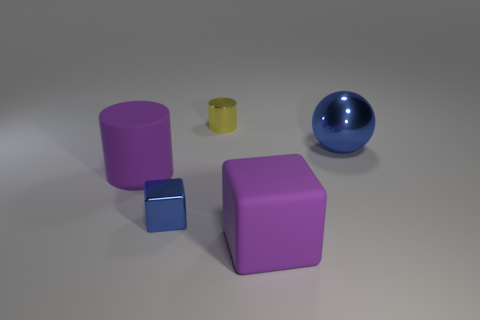Add 3 big brown blocks. How many objects exist? 8 Subtract all purple cylinders. How many cylinders are left? 1 Subtract 1 cubes. How many cubes are left? 1 Add 3 small metal cylinders. How many small metal cylinders are left? 4 Add 5 big spheres. How many big spheres exist? 6 Subtract 0 purple balls. How many objects are left? 5 Subtract all cylinders. How many objects are left? 3 Subtract all brown blocks. Subtract all yellow balls. How many blocks are left? 2 Subtract all gray balls. How many blue cubes are left? 1 Subtract all yellow cylinders. Subtract all small blue cubes. How many objects are left? 3 